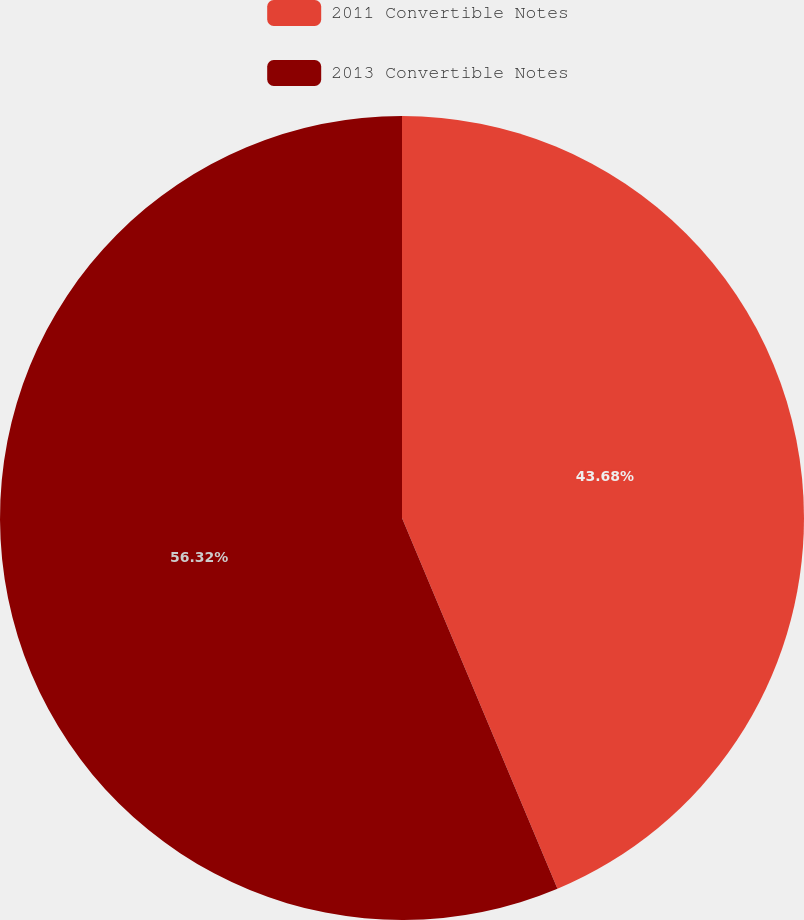<chart> <loc_0><loc_0><loc_500><loc_500><pie_chart><fcel>2011 Convertible Notes<fcel>2013 Convertible Notes<nl><fcel>43.68%<fcel>56.32%<nl></chart> 